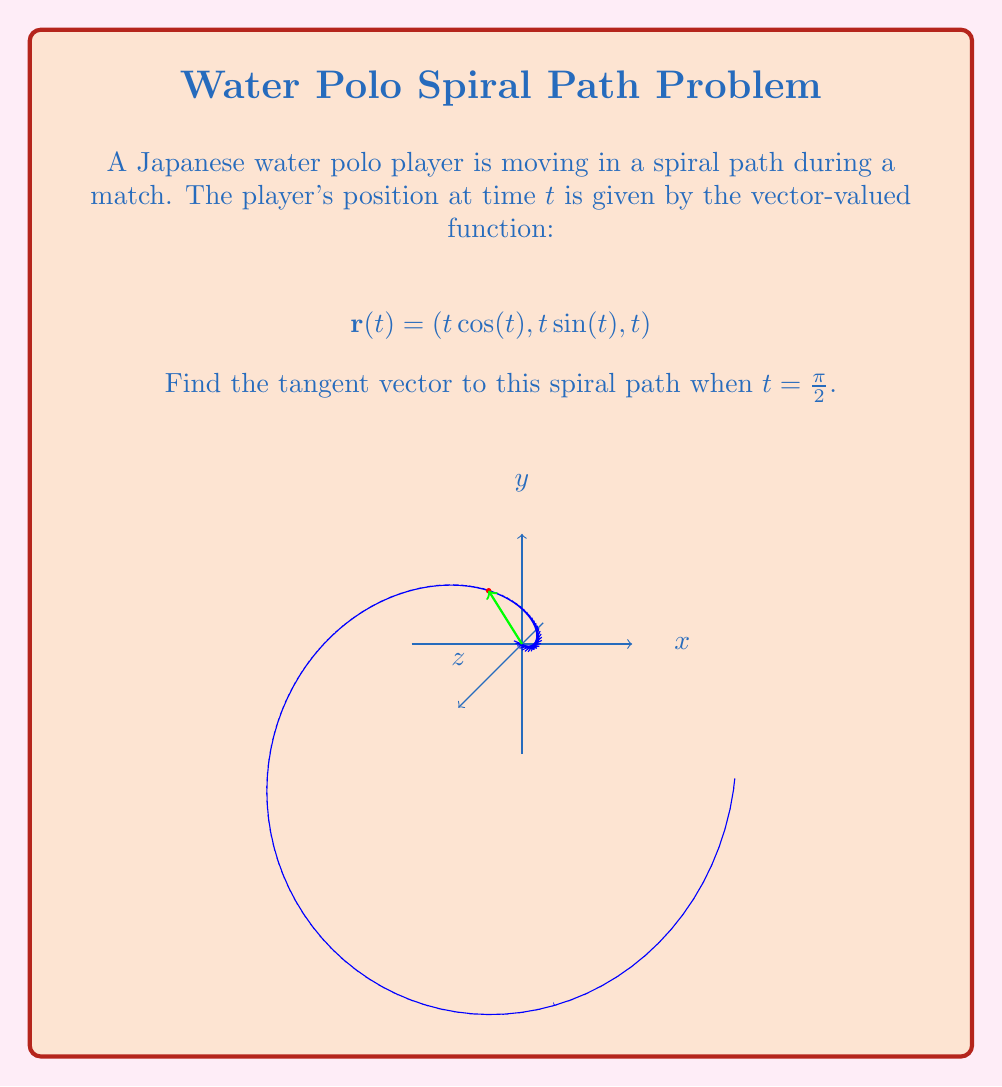Give your solution to this math problem. To find the tangent vector, we need to follow these steps:

1) The tangent vector is given by the derivative of the position vector $\mathbf{r}(t)$ with respect to $t$. Let's call this $\mathbf{r}'(t)$.

2) We need to differentiate each component of $\mathbf{r}(t)$:

   $$\mathbf{r}'(t) = \left(\frac{d}{dt}(t \cos(t)), \frac{d}{dt}(t \sin(t)), \frac{d}{dt}(t)\right)$$

3) Using the product rule and chain rule:

   $$\mathbf{r}'(t) = (\cos(t) - t \sin(t), \sin(t) + t \cos(t), 1)$$

4) Now, we need to evaluate this at $t = \frac{\pi}{2}$:

   $$\mathbf{r}'(\frac{\pi}{2}) = (\cos(\frac{\pi}{2}) - \frac{\pi}{2} \sin(\frac{\pi}{2}), \sin(\frac{\pi}{2}) + \frac{\pi}{2} \cos(\frac{\pi}{2}), 1)$$

5) Simplify, knowing that $\cos(\frac{\pi}{2}) = 0$ and $\sin(\frac{\pi}{2}) = 1$:

   $$\mathbf{r}'(\frac{\pi}{2}) = (0 - \frac{\pi}{2} \cdot 1, 1 + \frac{\pi}{2} \cdot 0, 1)$$

6) This simplifies to:

   $$\mathbf{r}'(\frac{\pi}{2}) = (-\frac{\pi}{2}, 1, 1)$$

This vector represents the tangent to the spiral path at $t = \frac{\pi}{2}$.
Answer: $(-\frac{\pi}{2}, 1, 1)$ 